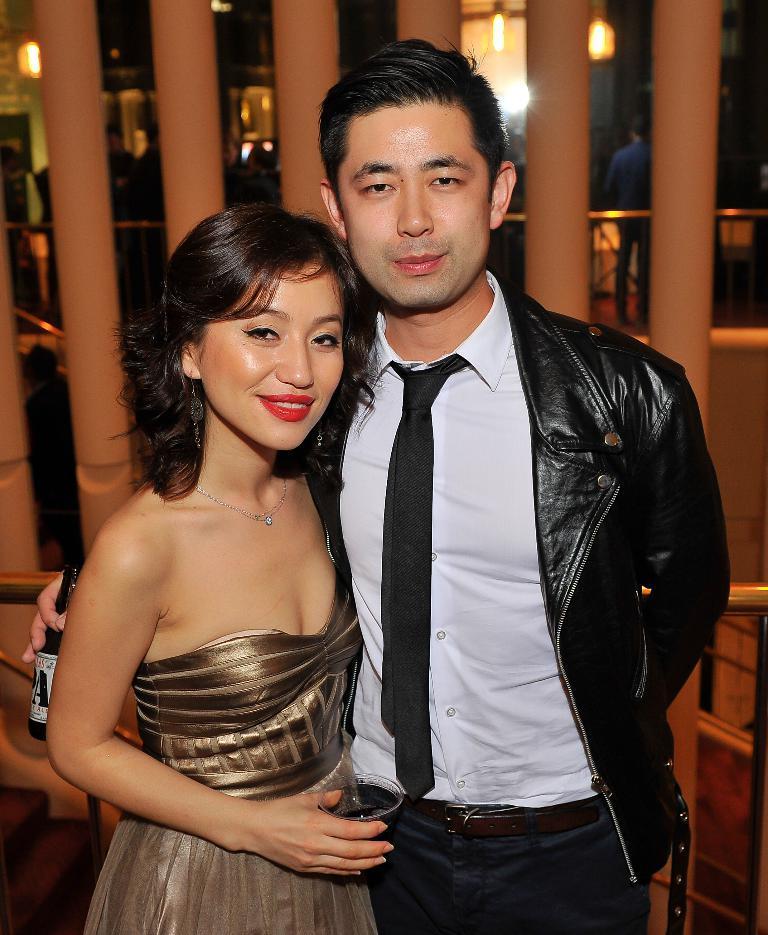How would you summarize this image in a sentence or two? This picture seems to be clicked inside the room. On the right we can see a man wearing black color jacket, holding a glass bottle and standing and we can see a woman holding a glass of drink, smiling and standing. In the background we can see the pillars, lights, metal rod, person and many other objects. 